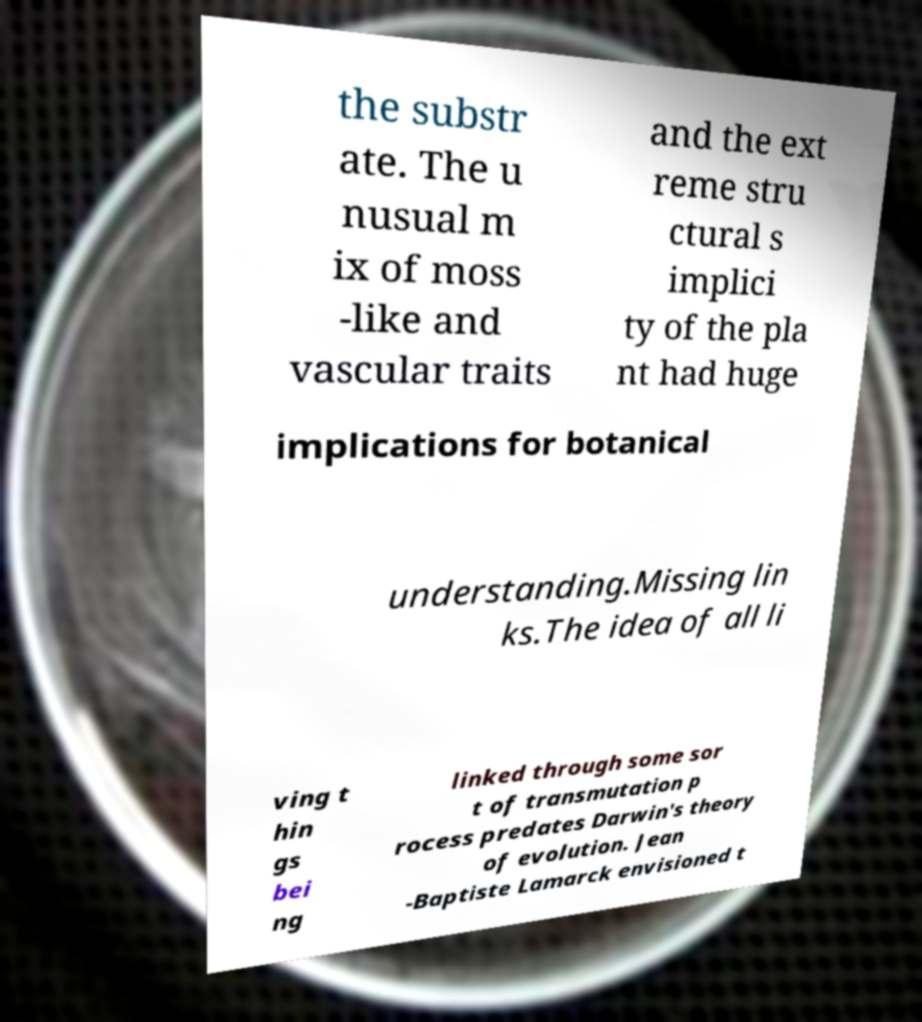Please read and relay the text visible in this image. What does it say? the substr ate. The u nusual m ix of moss -like and vascular traits and the ext reme stru ctural s implici ty of the pla nt had huge implications for botanical understanding.Missing lin ks.The idea of all li ving t hin gs bei ng linked through some sor t of transmutation p rocess predates Darwin's theory of evolution. Jean -Baptiste Lamarck envisioned t 